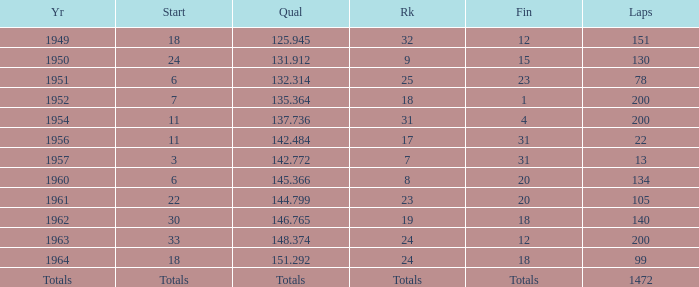Name the rank with laps of 200 and qual of 148.374 24.0. 